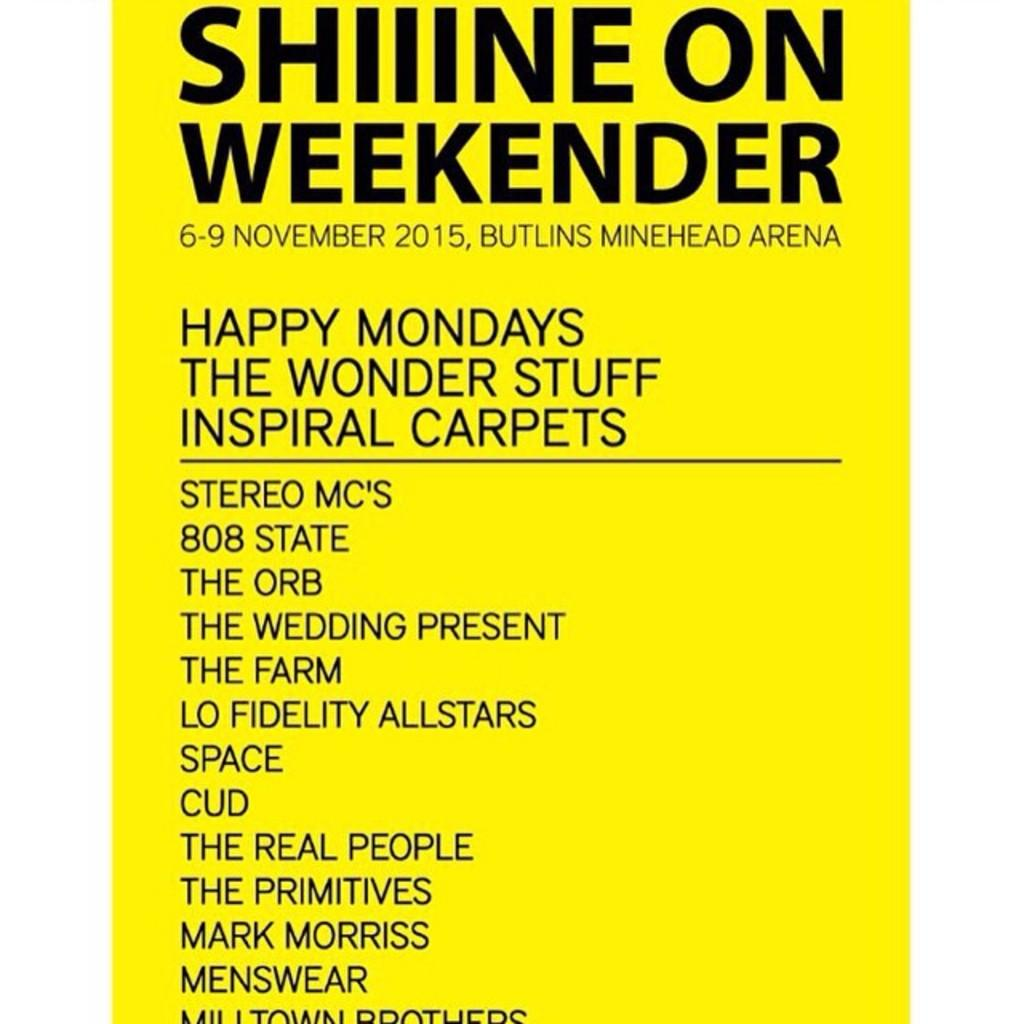<image>
Give a short and clear explanation of the subsequent image. An event poster for Shiiine on Weekender at the Butlins Minehead Arena 